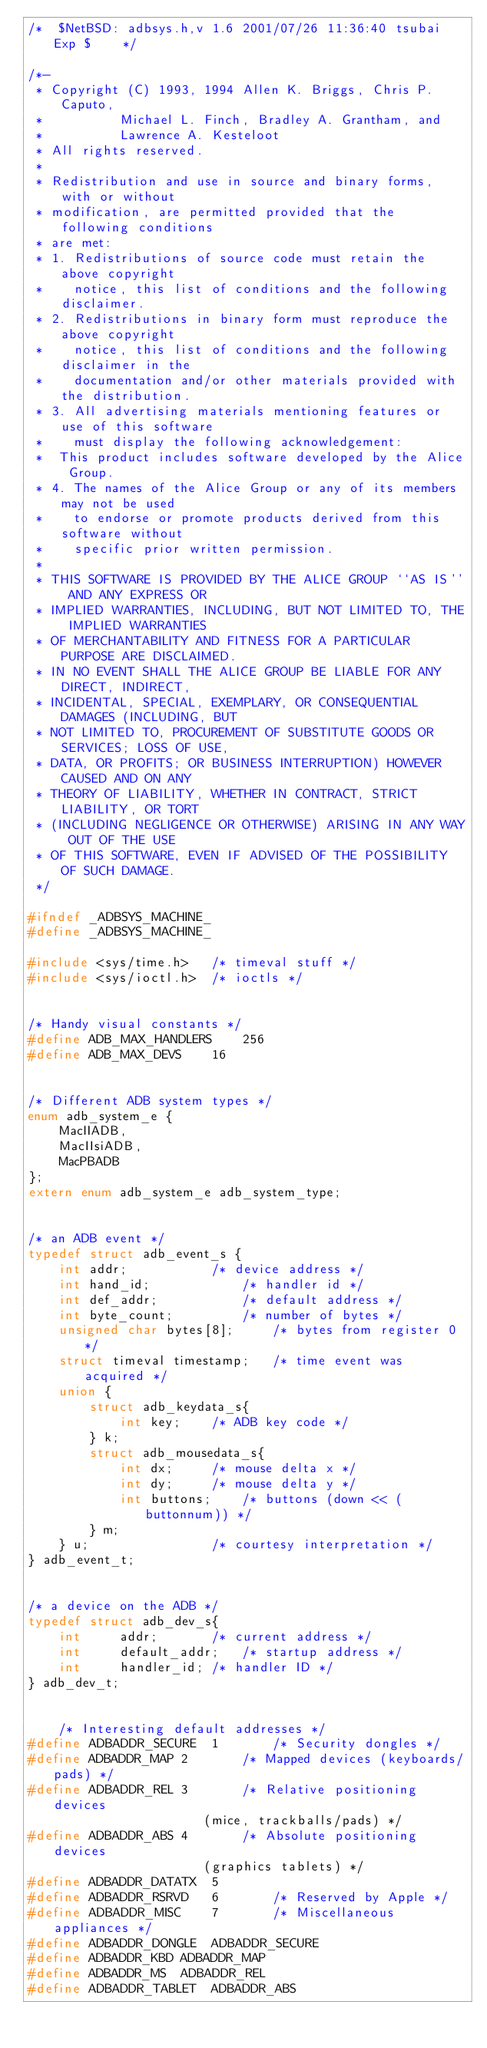<code> <loc_0><loc_0><loc_500><loc_500><_C_>/*	$NetBSD: adbsys.h,v 1.6 2001/07/26 11:36:40 tsubai Exp $	*/

/*-
 * Copyright (C) 1993, 1994	Allen K. Briggs, Chris P. Caputo,
 *			Michael L. Finch, Bradley A. Grantham, and
 *			Lawrence A. Kesteloot
 * All rights reserved.
 *
 * Redistribution and use in source and binary forms, with or without
 * modification, are permitted provided that the following conditions
 * are met:
 * 1. Redistributions of source code must retain the above copyright
 *    notice, this list of conditions and the following disclaimer.
 * 2. Redistributions in binary form must reproduce the above copyright
 *    notice, this list of conditions and the following disclaimer in the
 *    documentation and/or other materials provided with the distribution.
 * 3. All advertising materials mentioning features or use of this software
 *    must display the following acknowledgement:
 *	This product includes software developed by the Alice Group.
 * 4. The names of the Alice Group or any of its members may not be used
 *    to endorse or promote products derived from this software without
 *    specific prior written permission.
 *
 * THIS SOFTWARE IS PROVIDED BY THE ALICE GROUP ``AS IS'' AND ANY EXPRESS OR
 * IMPLIED WARRANTIES, INCLUDING, BUT NOT LIMITED TO, THE IMPLIED WARRANTIES
 * OF MERCHANTABILITY AND FITNESS FOR A PARTICULAR PURPOSE ARE DISCLAIMED.
 * IN NO EVENT SHALL THE ALICE GROUP BE LIABLE FOR ANY DIRECT, INDIRECT,
 * INCIDENTAL, SPECIAL, EXEMPLARY, OR CONSEQUENTIAL DAMAGES (INCLUDING, BUT
 * NOT LIMITED TO, PROCUREMENT OF SUBSTITUTE GOODS OR SERVICES; LOSS OF USE,
 * DATA, OR PROFITS; OR BUSINESS INTERRUPTION) HOWEVER CAUSED AND ON ANY
 * THEORY OF LIABILITY, WHETHER IN CONTRACT, STRICT LIABILITY, OR TORT
 * (INCLUDING NEGLIGENCE OR OTHERWISE) ARISING IN ANY WAY OUT OF THE USE
 * OF THIS SOFTWARE, EVEN IF ADVISED OF THE POSSIBILITY OF SUCH DAMAGE.
 */

#ifndef _ADBSYS_MACHINE_
#define _ADBSYS_MACHINE_

#include <sys/time.h>	/* timeval stuff */
#include <sys/ioctl.h>	/* ioctls */


/* Handy visual constants */
#define ADB_MAX_HANDLERS	256
#define ADB_MAX_DEVS	16


/* Different ADB system types */
enum adb_system_e {
	MacIIADB,
	MacIIsiADB,
	MacPBADB
};
extern enum adb_system_e adb_system_type;


/* an ADB event */
typedef struct adb_event_s {
	int addr;			/* device address */
	int hand_id;			/* handler id */
	int def_addr;			/* default address */
	int byte_count;			/* number of bytes */
	unsigned char bytes[8];		/* bytes from register 0 */
	struct timeval timestamp;	/* time event was acquired */
	union {
		struct adb_keydata_s{
			int key;	/* ADB key code */
		} k;
		struct adb_mousedata_s{
			int dx;		/* mouse delta x */
			int dy;		/* mouse delta y */
			int buttons;	/* buttons (down << (buttonnum)) */
		} m;
	} u;				/* courtesy interpretation */
} adb_event_t;


/* a device on the ADB */
typedef struct adb_dev_s{
	int		addr;		/* current address */
	int		default_addr;	/* startup address */
	int		handler_id;	/* handler ID */
} adb_dev_t;


	/* Interesting default addresses */
#define	ADBADDR_SECURE	1		/* Security dongles */
#define ADBADDR_MAP	2		/* Mapped devices (keyboards/pads) */
#define ADBADDR_REL	3		/* Relative positioning devices
					   (mice, trackballs/pads) */
#define ADBADDR_ABS	4		/* Absolute positioning devices
					   (graphics tablets) */
#define ADBADDR_DATATX	5
#define ADBADDR_RSRVD	6		/* Reserved by Apple */
#define ADBADDR_MISC	7		/* Miscellaneous appliances */
#define ADBADDR_DONGLE	ADBADDR_SECURE
#define ADBADDR_KBD	ADBADDR_MAP
#define ADBADDR_MS	ADBADDR_REL
#define ADBADDR_TABLET	ADBADDR_ABS</code> 